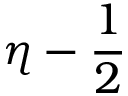<formula> <loc_0><loc_0><loc_500><loc_500>\eta - \frac { 1 } { 2 }</formula> 